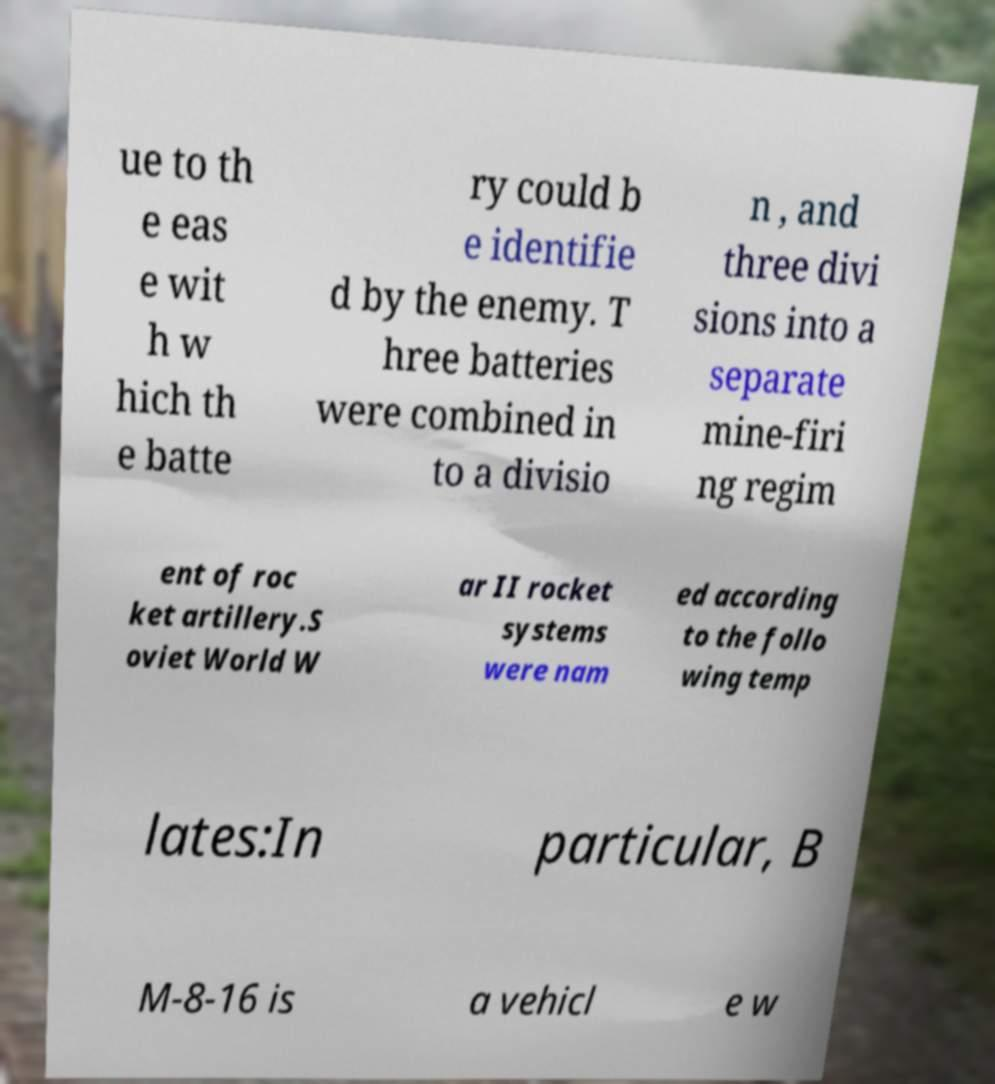I need the written content from this picture converted into text. Can you do that? ue to th e eas e wit h w hich th e batte ry could b e identifie d by the enemy. T hree batteries were combined in to a divisio n , and three divi sions into a separate mine-firi ng regim ent of roc ket artillery.S oviet World W ar II rocket systems were nam ed according to the follo wing temp lates:In particular, B M-8-16 is a vehicl e w 